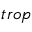Convert formula to latex. <formula><loc_0><loc_0><loc_500><loc_500>_ { t r o p }</formula> 